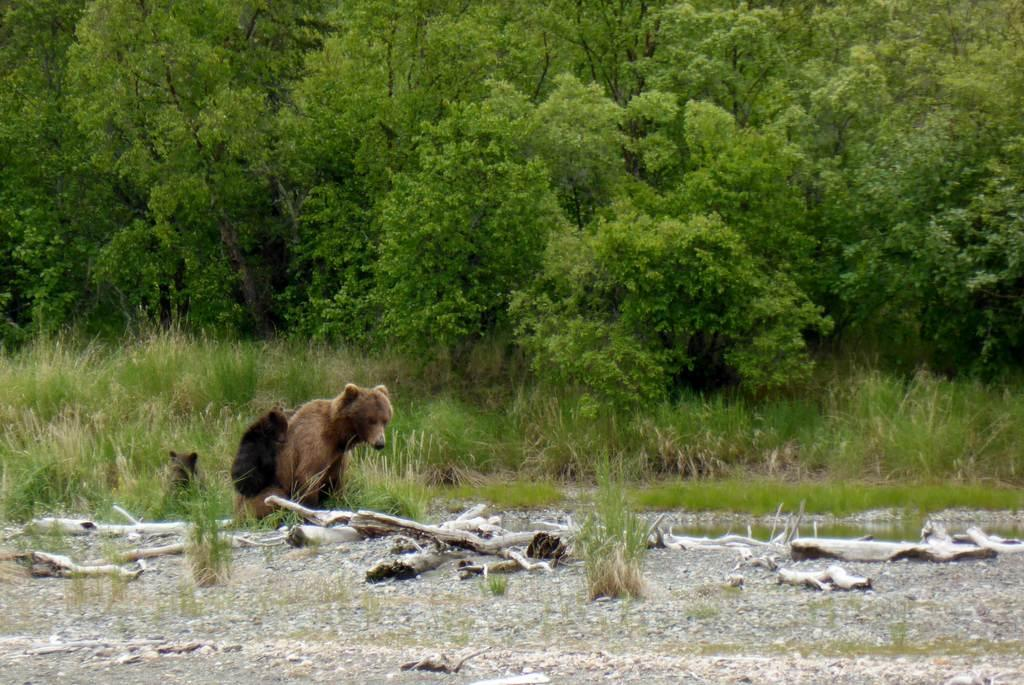What type of objects can be seen in the image? There are wooden objects in the image. What other living creatures are present in the image? There are animals in the image. What type of natural environment is visible in the image? There is grass and water visible in the image. What can be seen in the background of the image? There are trees in the background of the image. What color is the girl's sweater in the image? There is no girl or sweater present in the image. What type of car can be seen driving through the water in the image? There is no car visible in the image; it only features wooden objects, animals, grass, water, and trees in the background. 